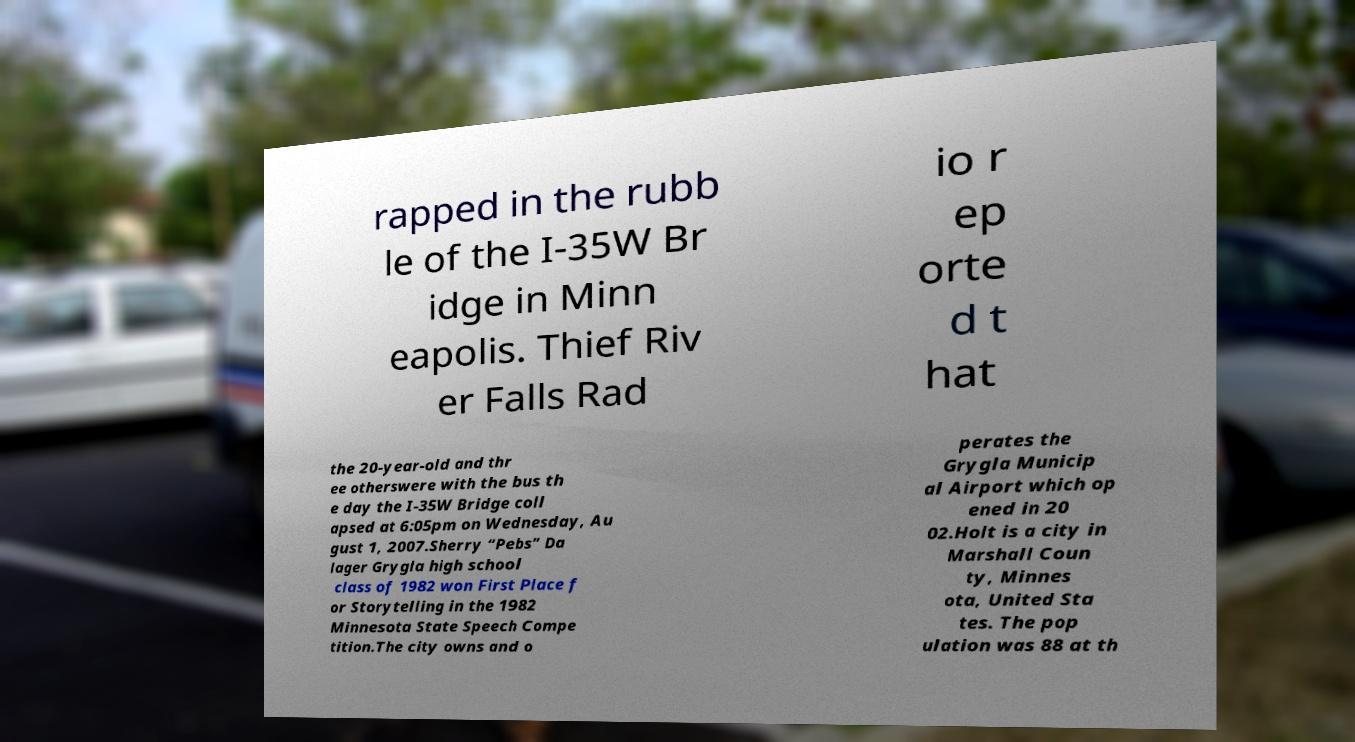What messages or text are displayed in this image? I need them in a readable, typed format. rapped in the rubb le of the I-35W Br idge in Minn eapolis. Thief Riv er Falls Rad io r ep orte d t hat the 20-year-old and thr ee otherswere with the bus th e day the I-35W Bridge coll apsed at 6:05pm on Wednesday, Au gust 1, 2007.Sherry “Pebs” Da lager Grygla high school class of 1982 won First Place f or Storytelling in the 1982 Minnesota State Speech Compe tition.The city owns and o perates the Grygla Municip al Airport which op ened in 20 02.Holt is a city in Marshall Coun ty, Minnes ota, United Sta tes. The pop ulation was 88 at th 